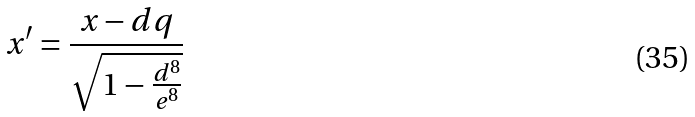Convert formula to latex. <formula><loc_0><loc_0><loc_500><loc_500>x ^ { \prime } = \frac { x - d q } { \sqrt { 1 - \frac { d ^ { 8 } } { e ^ { 8 } } } }</formula> 